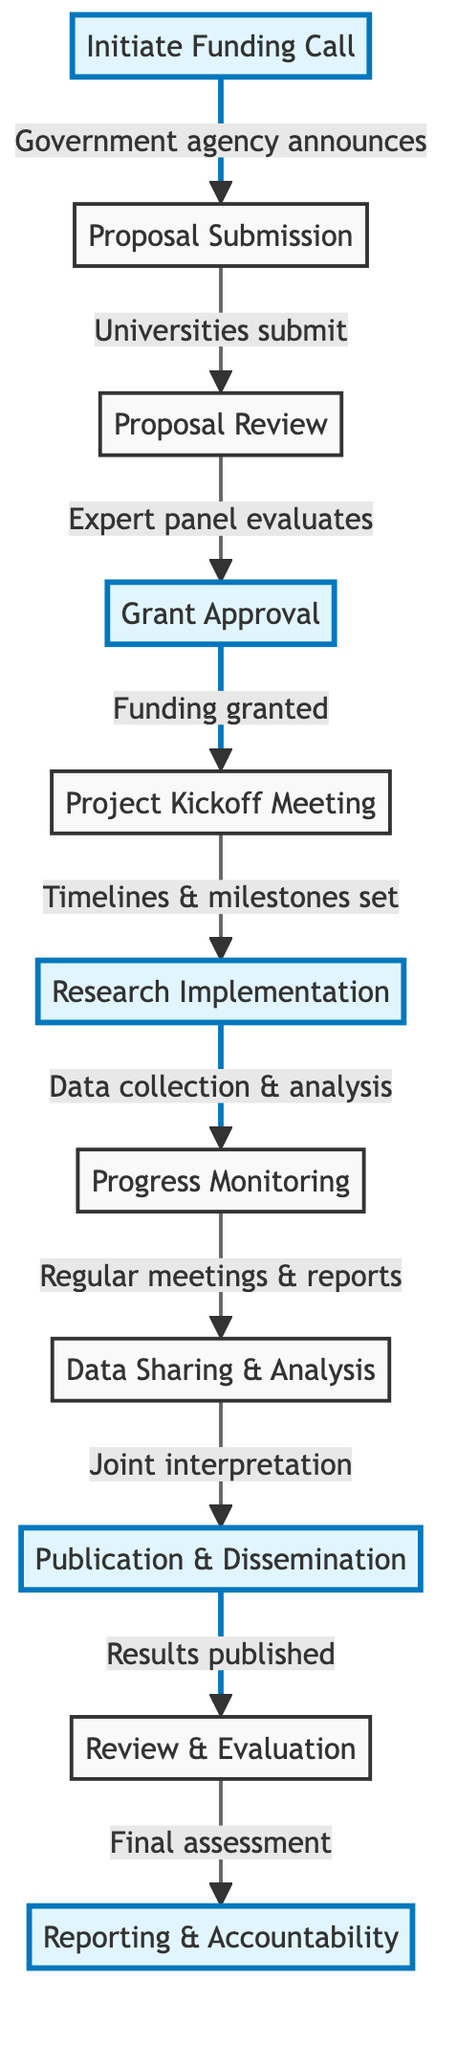What is the first step in the diagram? The first step is "Initiate Funding Call," which is the starting point of the collaboration workflow depicted in the diagram.
Answer: Initiate Funding Call How many steps are in total in the workflow? By counting each step listed in the diagram, there are a total of 11 steps, including both the starting and ending nodes.
Answer: 11 Which step comes immediately after "Grant Approval"? The step that follows "Grant Approval" according to the flowchart is "Project Kickoff Meeting."
Answer: Project Kickoff Meeting What type of meetings occur during the "Progress Monitoring" phase? In the "Progress Monitoring" phase, scheduled meetings occur to assess the ongoing research and gather feedback, as indicated in the description.
Answer: Regular meetings What is the relationship between "Data Sharing & Analysis" and "Publication & Dissemination"? Data Sharing & Analysis leads into Publication & Dissemination; data findings are interpreted together before formal results are published in scientific journals.
Answer: Joint interpretation How many highlighted steps are there in the diagram? The highlighted steps are "Initiate Funding Call," "Grant Approval," "Research Implementation," "Publication & Dissemination," and "Reporting & Accountability," making a total of 5 highlighted steps.
Answer: 5 What is the last step in the collaboration workflow? The final step in the workflow is "Reporting & Accountability," which concludes the joint research process and involves submitting a report.
Answer: Reporting & Accountability What action is taken after the "Proposal Review"? Following the Proposal Review, the next action taken is Grant Approval, where selected proposals are funded.
Answer: Grant Approval Which facility is mentioned for research in the implementation phase? The facility named in the Research Implementation phase is the Event Horizon Telescope, recognized for its contributions to black hole research.
Answer: Event Horizon Telescope 